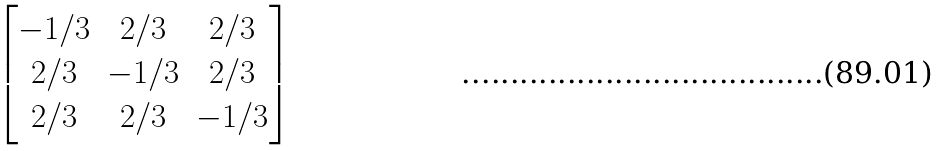Convert formula to latex. <formula><loc_0><loc_0><loc_500><loc_500>\begin{bmatrix} - 1 / 3 & 2 / 3 & 2 / 3 \\ 2 / 3 & - 1 / 3 & 2 / 3 \\ 2 / 3 & 2 / 3 & - 1 / 3 \end{bmatrix}</formula> 